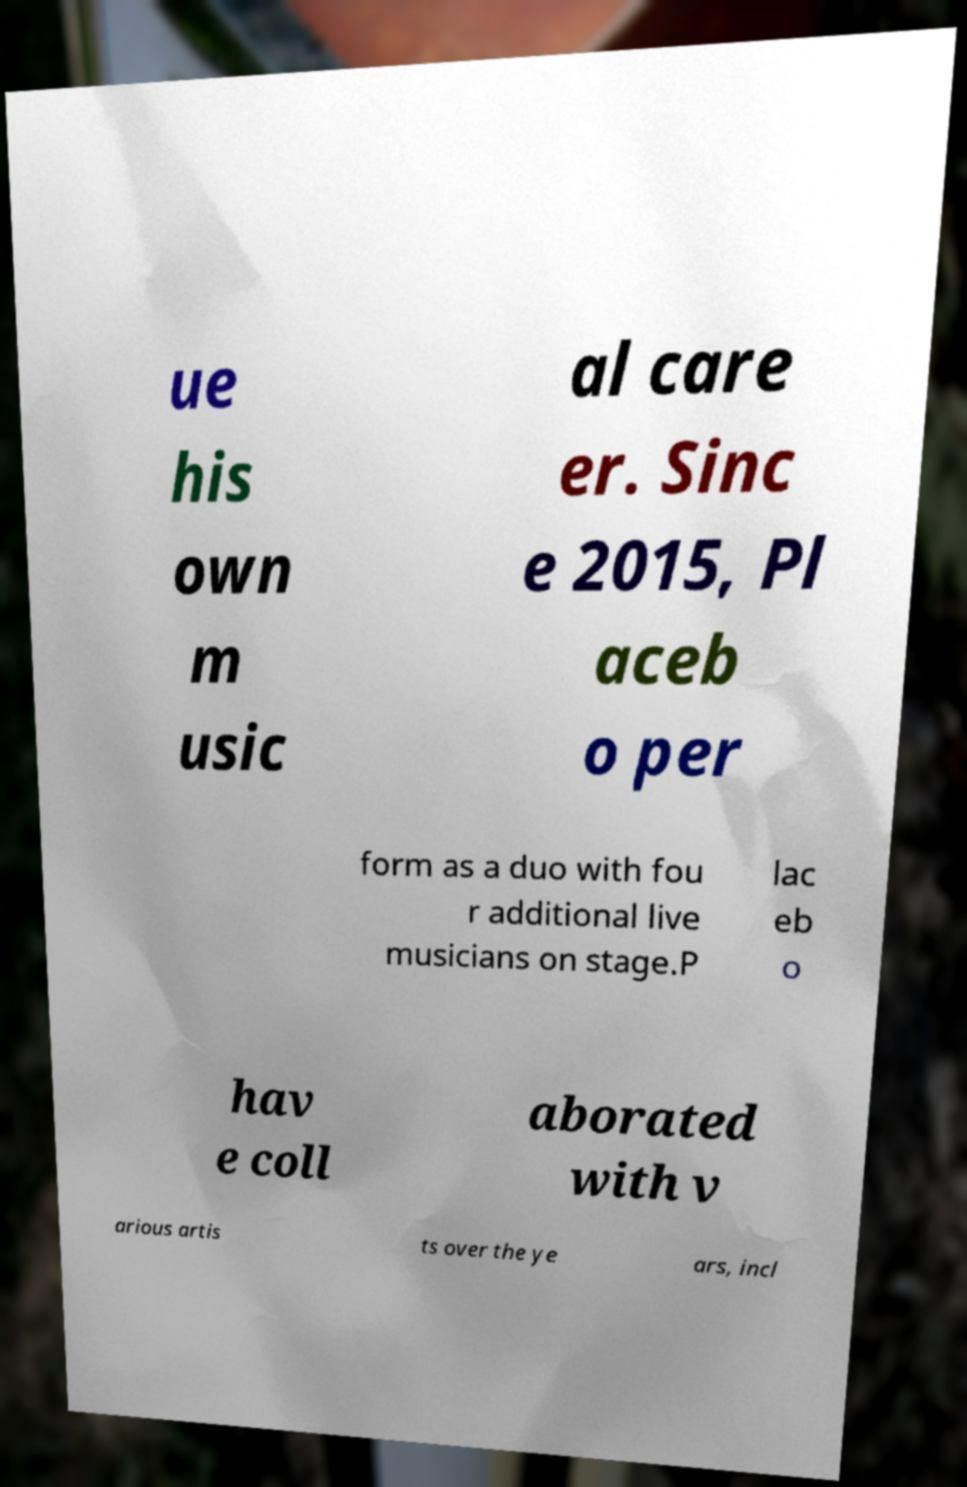Please identify and transcribe the text found in this image. ue his own m usic al care er. Sinc e 2015, Pl aceb o per form as a duo with fou r additional live musicians on stage.P lac eb o hav e coll aborated with v arious artis ts over the ye ars, incl 